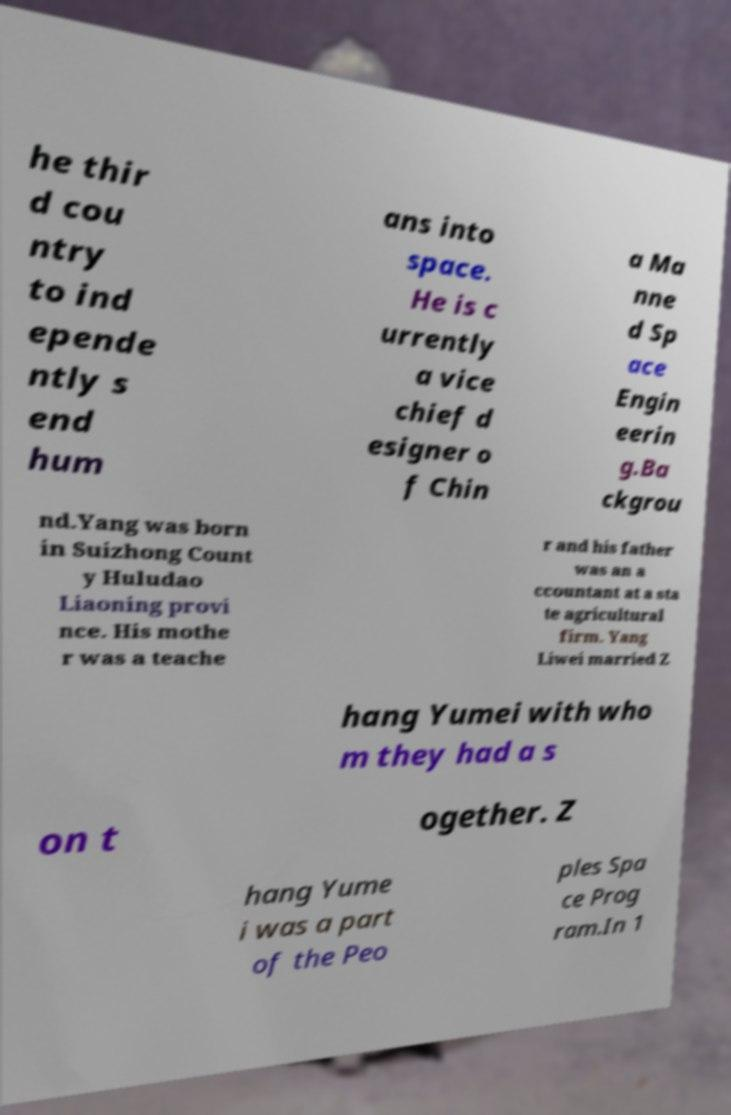For documentation purposes, I need the text within this image transcribed. Could you provide that? he thir d cou ntry to ind epende ntly s end hum ans into space. He is c urrently a vice chief d esigner o f Chin a Ma nne d Sp ace Engin eerin g.Ba ckgrou nd.Yang was born in Suizhong Count y Huludao Liaoning provi nce. His mothe r was a teache r and his father was an a ccountant at a sta te agricultural firm. Yang Liwei married Z hang Yumei with who m they had a s on t ogether. Z hang Yume i was a part of the Peo ples Spa ce Prog ram.In 1 